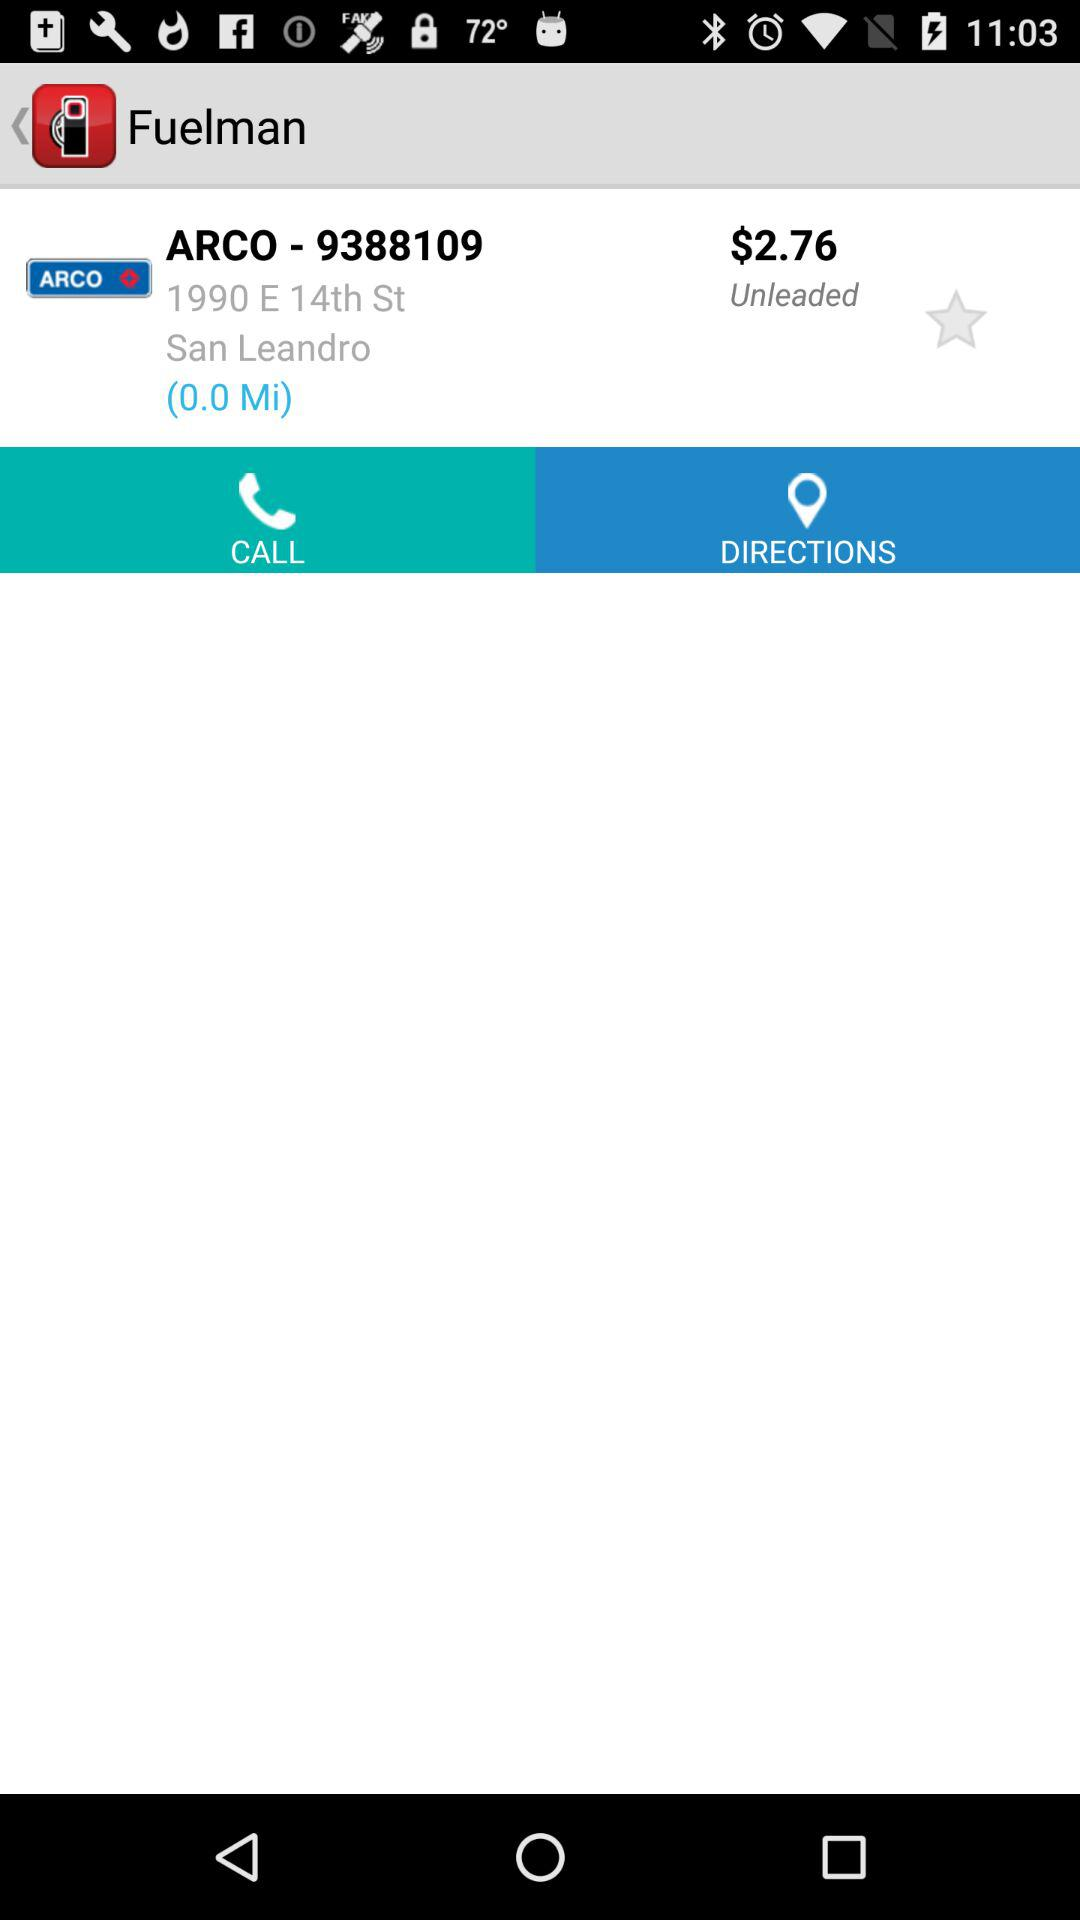How much is the price of unleaded gas?
Answer the question using a single word or phrase. $2.76 